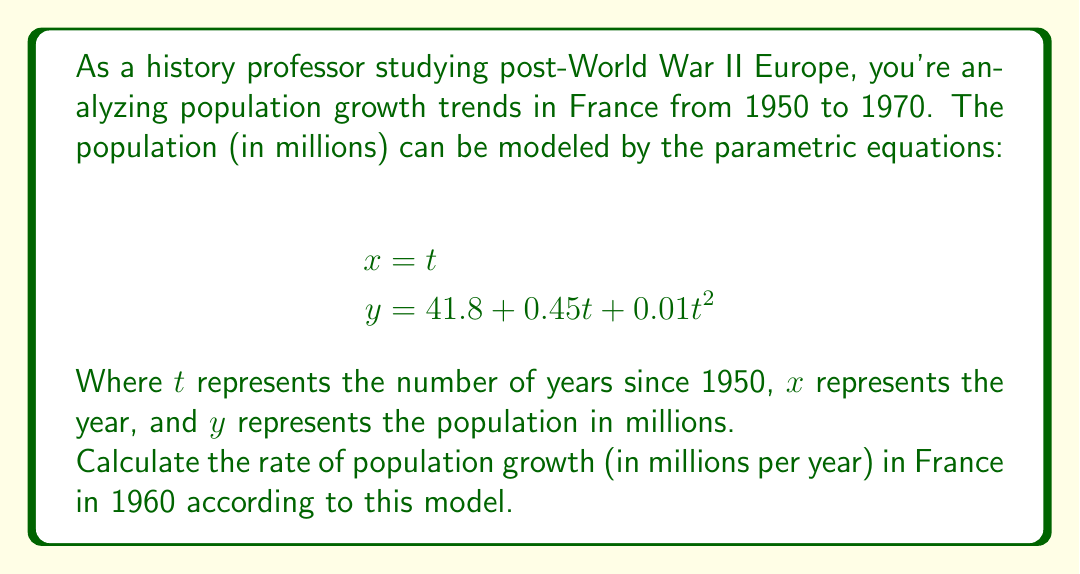Help me with this question. To solve this problem, we need to follow these steps:

1) First, we need to find the value of $t$ that corresponds to the year 1960:
   Since $t = 0$ corresponds to 1950, $t = 10$ corresponds to 1960.

2) The rate of population growth is given by the derivative $\frac{dy}{dt}$ at $t = 10$.

3) To find $\frac{dy}{dt}$, we differentiate the equation for $y$ with respect to $t$:
   
   $$\frac{dy}{dt} = 0.45 + 0.02t$$

4) Now we substitute $t = 10$ into this equation:
   
   $$\frac{dy}{dt}\bigg|_{t=10} = 0.45 + 0.02(10) = 0.45 + 0.2 = 0.65$$

Therefore, according to this model, the rate of population growth in France in 1960 was 0.65 million people per year.
Answer: 0.65 million people per year 